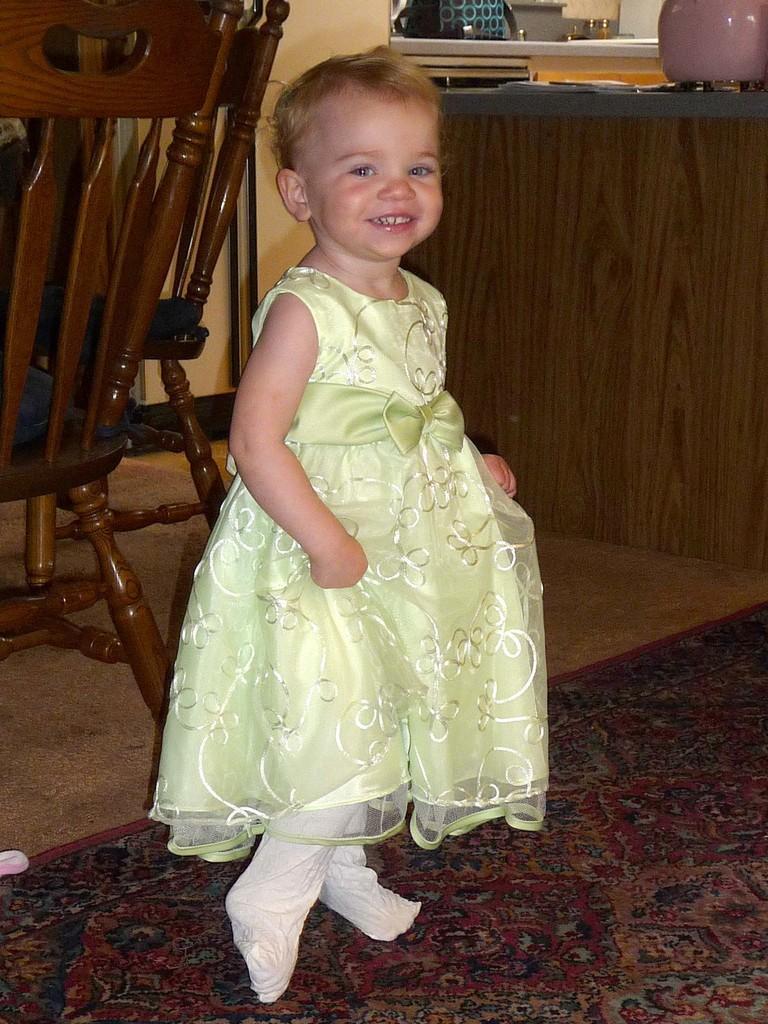Please provide a concise description of this image. In this image in the foreground there is one girl who is standing and smiling, and in the background there are some chairs and table. On the table there are some vessels and bowls, at the bottom there is one carpet. 